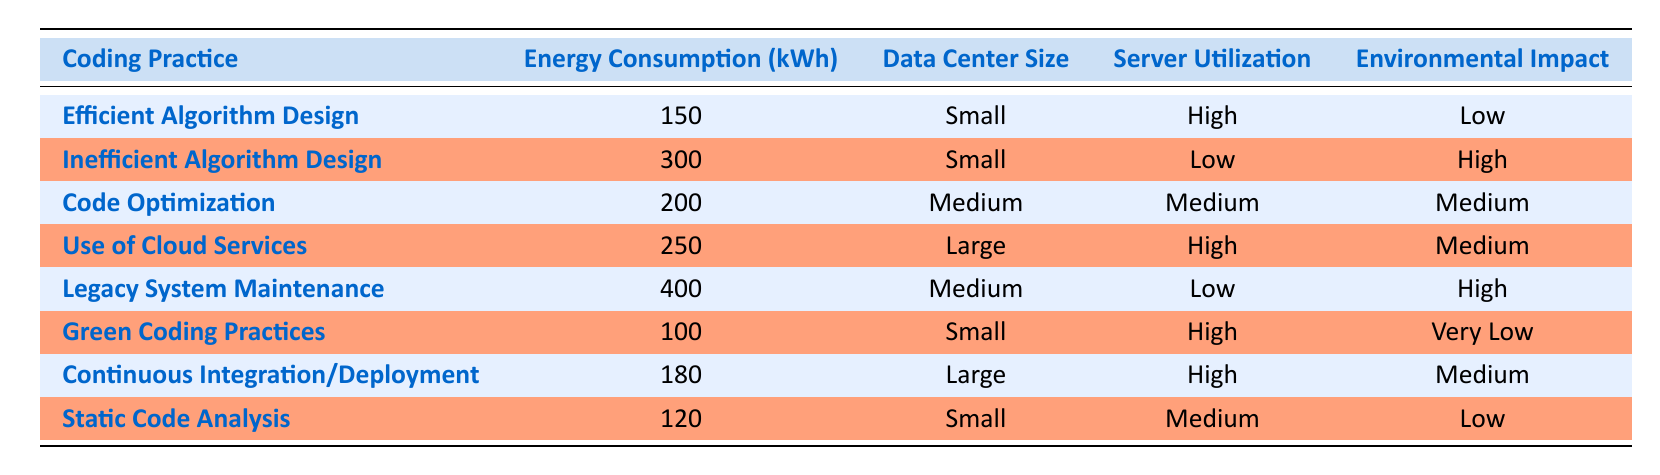What is the energy consumption of "Green Coding Practices"? The table indicates that the energy consumption for Green Coding Practices is 100 kWh.
Answer: 100 kWh Which coding practice has the highest energy consumption? According to the table, Legacy System Maintenance has the highest energy consumption at 400 kWh.
Answer: Legacy System Maintenance Is the environmental impact of Code Optimization low? The environmental impact of Code Optimization is noted as medium in the table, so it is not low.
Answer: No What is the total energy consumption of the coding practices in small data centers? The total energy consumption for small data centers can be calculated by summing the values for Efficient Algorithm Design (150 kWh), Inefficient Algorithm Design (300 kWh), Green Coding Practices (100 kWh), and Static Code Analysis (120 kWh), which gives 150 + 300 + 100 + 120 = 670 kWh.
Answer: 670 kWh Are there any coding practices associated with very low environmental impact? The table shows that Green Coding Practices have a very low environmental impact, confirming that there is at least one such practice.
Answer: Yes What is the difference in energy consumption between Inefficient Algorithm Design and Efficient Algorithm Design? Energy consumption for Inefficient Algorithm Design is 300 kWh and for Efficient Algorithm Design it is 150 kWh. The difference is 300 - 150 = 150 kWh.
Answer: 150 kWh Which coding practice has a medium server utilization in a medium data center? The table lists Code Optimization as having medium server utilization in a medium data center.
Answer: Code Optimization What is the average energy consumption of coding practices that have high server utilization? The relevant coding practices are Efficient Algorithm Design (150 kWh), Use of Cloud Services (250 kWh), Green Coding Practices (100 kWh), and Continuous Integration/Deployment (180 kWh). Summing these gives 150 + 250 + 100 + 180 = 680 kWh, and dividing by 4 gives an average of 680 / 4 = 170 kWh.
Answer: 170 kWh 